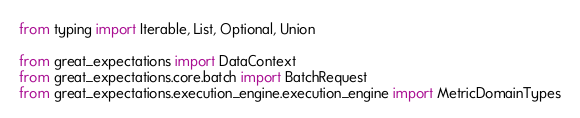<code> <loc_0><loc_0><loc_500><loc_500><_Python_>from typing import Iterable, List, Optional, Union

from great_expectations import DataContext
from great_expectations.core.batch import BatchRequest
from great_expectations.execution_engine.execution_engine import MetricDomainTypes</code> 